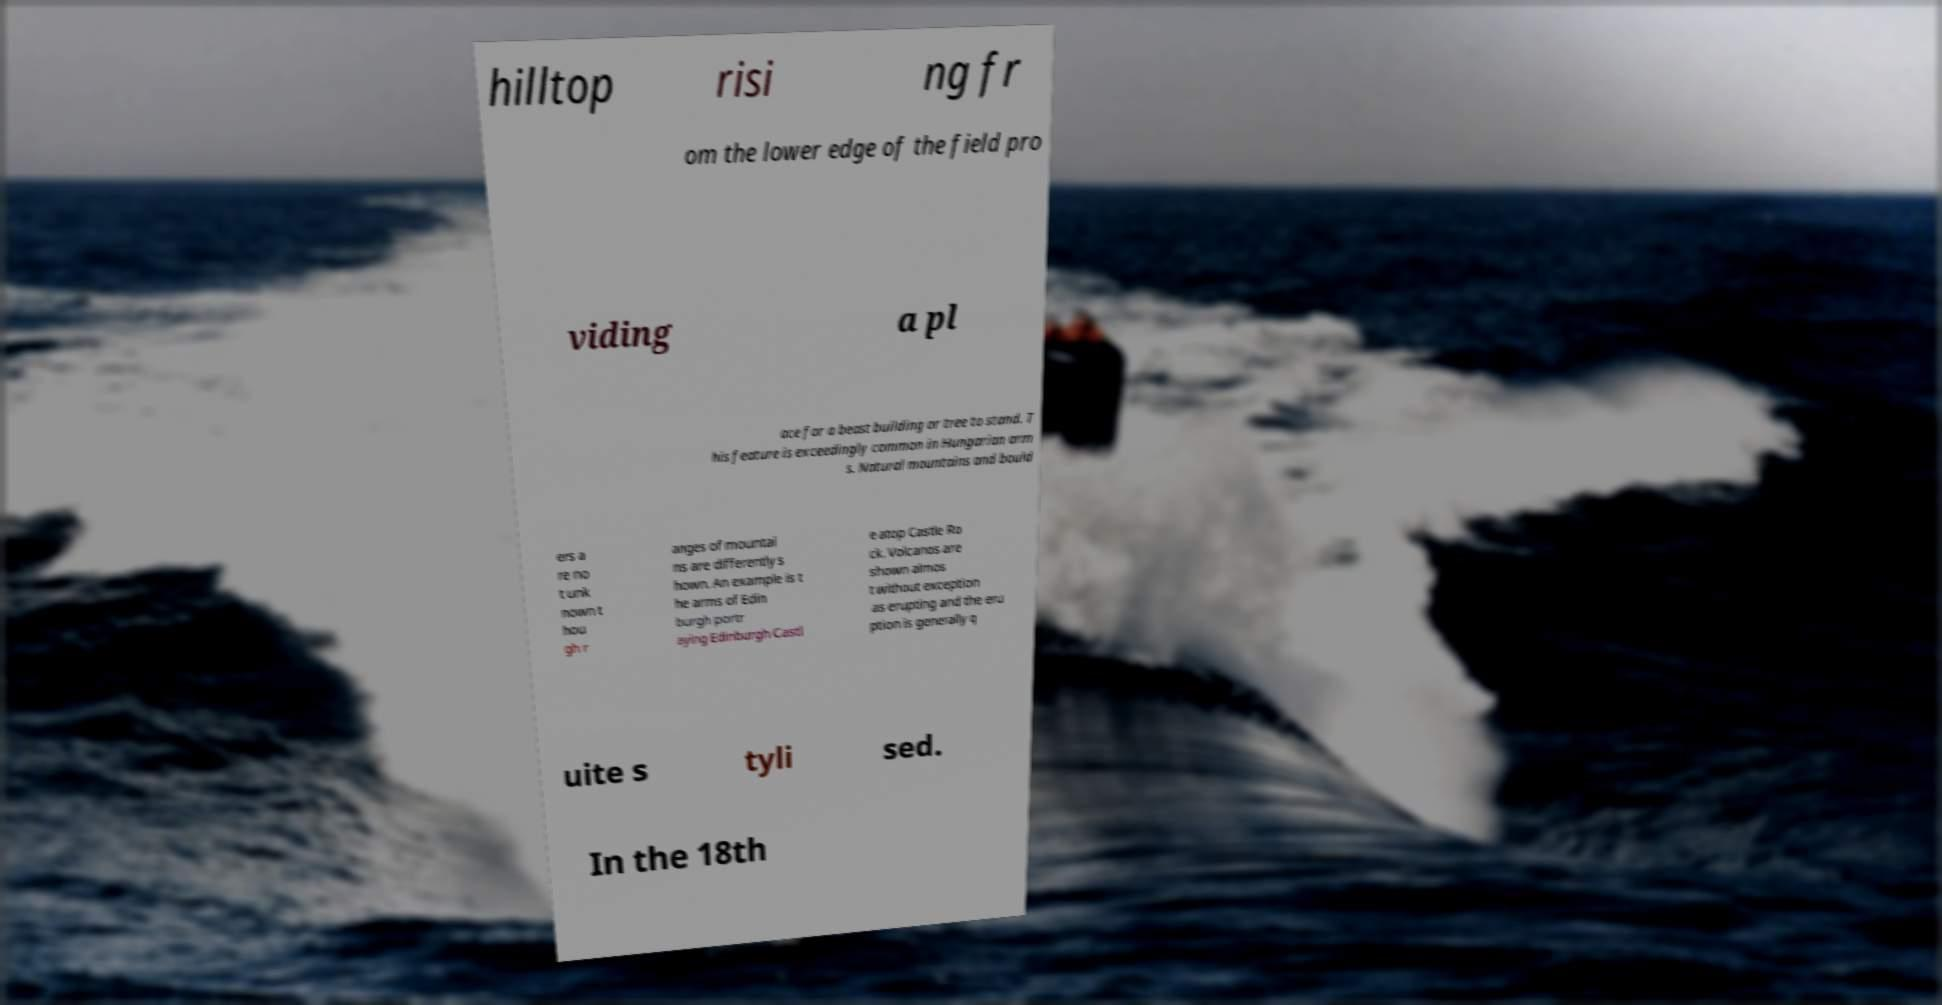Can you read and provide the text displayed in the image?This photo seems to have some interesting text. Can you extract and type it out for me? hilltop risi ng fr om the lower edge of the field pro viding a pl ace for a beast building or tree to stand. T his feature is exceedingly common in Hungarian arm s. Natural mountains and bould ers a re no t unk nown t hou gh r anges of mountai ns are differently s hown. An example is t he arms of Edin burgh portr aying Edinburgh Castl e atop Castle Ro ck. Volcanos are shown almos t without exception as erupting and the eru ption is generally q uite s tyli sed. In the 18th 